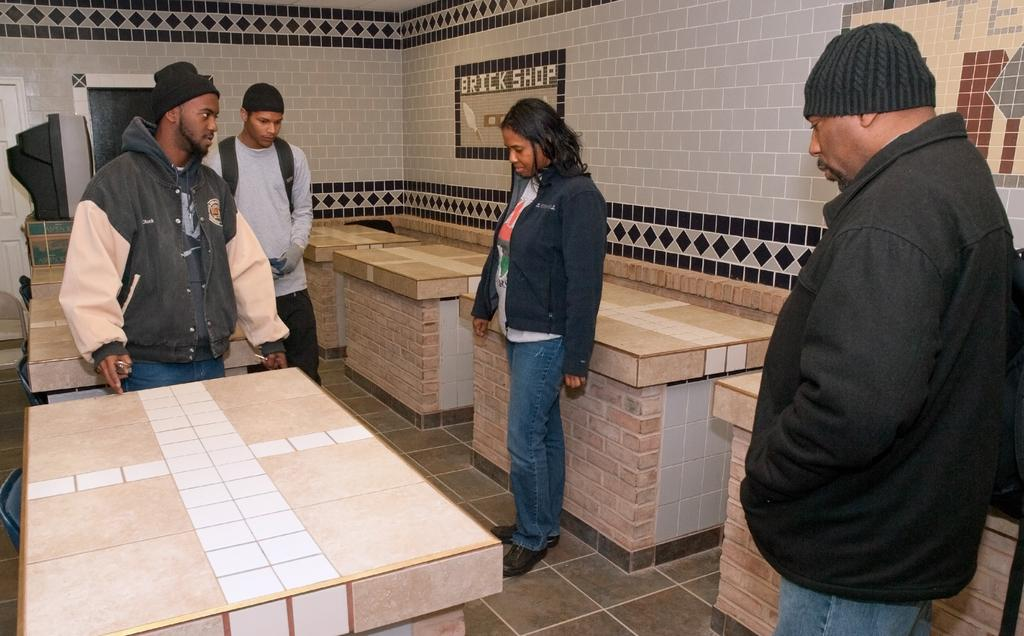What are the people in the image doing? The people in the image are standing on the ground. What type of material is used to construct the tables in the image? The tables in the image are made up of stone bricks. What can be seen on the wall in the background of the image? There are tiles on the wall in the background of the image. Can you tell me how many kittens are sitting on the pickle in the image? There are no kittens or pickles present in the image. 